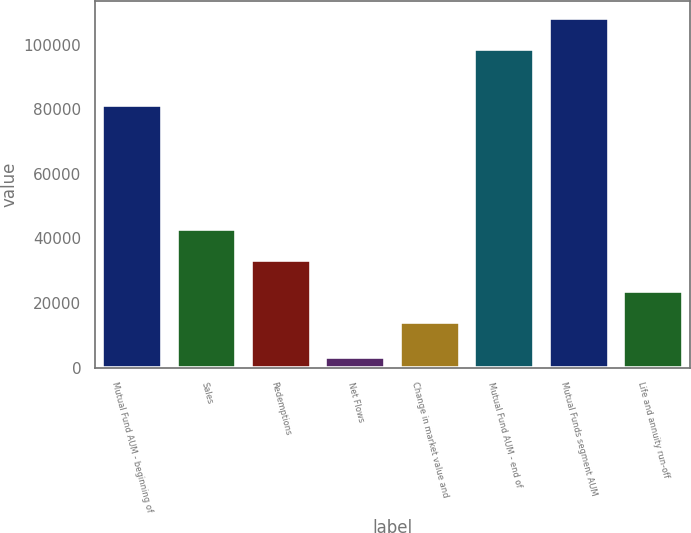Convert chart. <chart><loc_0><loc_0><loc_500><loc_500><bar_chart><fcel>Mutual Fund AUM - beginning of<fcel>Sales<fcel>Redemptions<fcel>Net Flows<fcel>Change in market value and<fcel>Mutual Fund AUM - end of<fcel>Mutual Funds segment AUM<fcel>Life and annuity run-off<nl><fcel>81298<fcel>42820.5<fcel>33236<fcel>3245<fcel>14067<fcel>98610<fcel>108194<fcel>23651.5<nl></chart> 